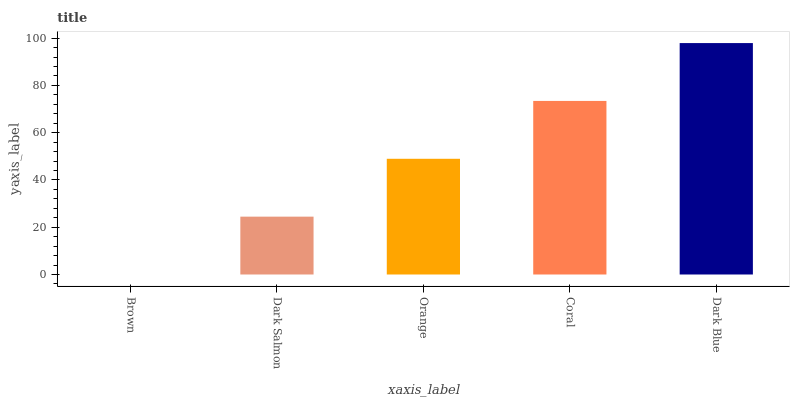Is Dark Salmon the minimum?
Answer yes or no. No. Is Dark Salmon the maximum?
Answer yes or no. No. Is Dark Salmon greater than Brown?
Answer yes or no. Yes. Is Brown less than Dark Salmon?
Answer yes or no. Yes. Is Brown greater than Dark Salmon?
Answer yes or no. No. Is Dark Salmon less than Brown?
Answer yes or no. No. Is Orange the high median?
Answer yes or no. Yes. Is Orange the low median?
Answer yes or no. Yes. Is Dark Blue the high median?
Answer yes or no. No. Is Dark Blue the low median?
Answer yes or no. No. 